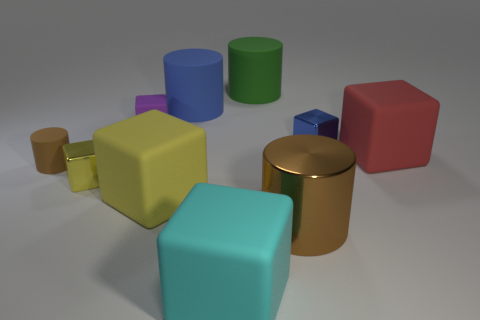Subtract 2 blocks. How many blocks are left? 4 Subtract all large red blocks. How many blocks are left? 5 Subtract all blue cubes. How many cubes are left? 5 Subtract all purple blocks. Subtract all blue spheres. How many blocks are left? 5 Subtract all cylinders. How many objects are left? 6 Add 5 large brown metallic cylinders. How many large brown metallic cylinders are left? 6 Add 1 green matte cylinders. How many green matte cylinders exist? 2 Subtract 2 brown cylinders. How many objects are left? 8 Subtract all small yellow things. Subtract all metal cylinders. How many objects are left? 8 